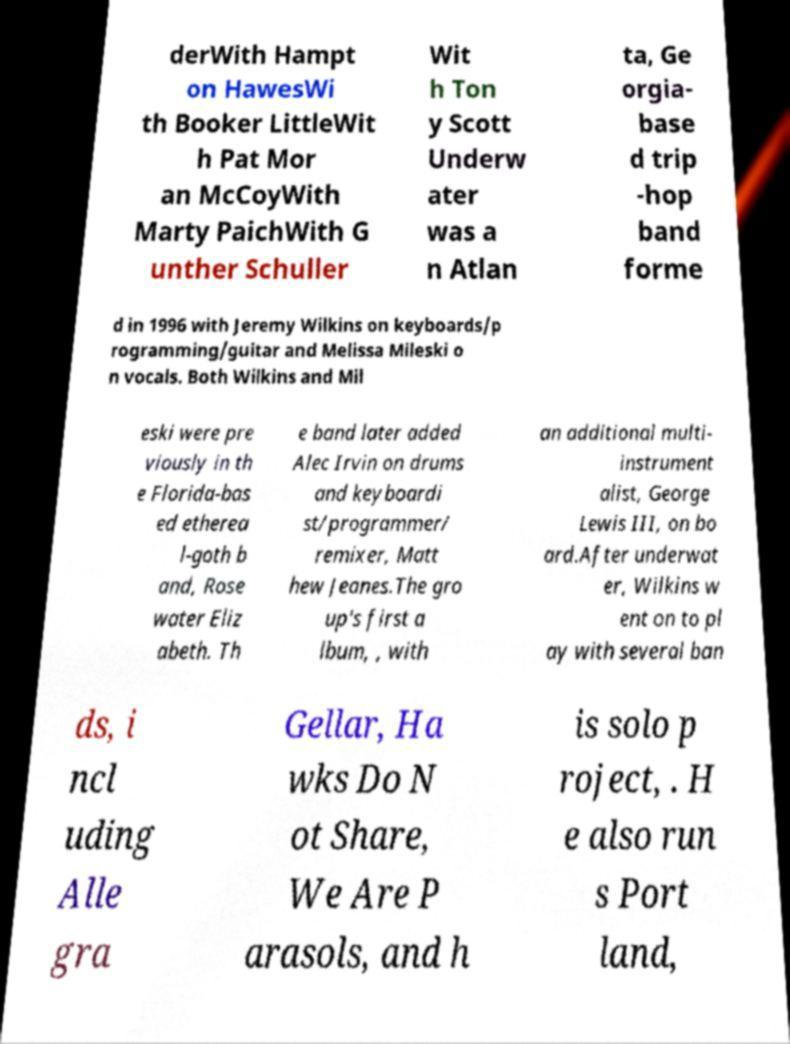Can you read and provide the text displayed in the image?This photo seems to have some interesting text. Can you extract and type it out for me? derWith Hampt on HawesWi th Booker LittleWit h Pat Mor an McCoyWith Marty PaichWith G unther Schuller Wit h Ton y Scott Underw ater was a n Atlan ta, Ge orgia- base d trip -hop band forme d in 1996 with Jeremy Wilkins on keyboards/p rogramming/guitar and Melissa Mileski o n vocals. Both Wilkins and Mil eski were pre viously in th e Florida-bas ed etherea l-goth b and, Rose water Eliz abeth. Th e band later added Alec Irvin on drums and keyboardi st/programmer/ remixer, Matt hew Jeanes.The gro up's first a lbum, , with an additional multi- instrument alist, George Lewis III, on bo ard.After underwat er, Wilkins w ent on to pl ay with several ban ds, i ncl uding Alle gra Gellar, Ha wks Do N ot Share, We Are P arasols, and h is solo p roject, . H e also run s Port land, 